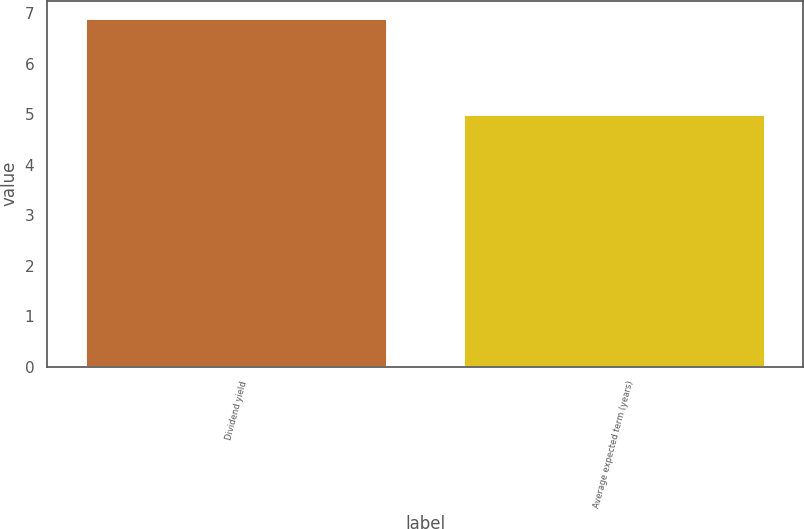Convert chart. <chart><loc_0><loc_0><loc_500><loc_500><bar_chart><fcel>Dividend yield<fcel>Average expected term (years)<nl><fcel>6.9<fcel>5<nl></chart> 